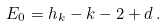<formula> <loc_0><loc_0><loc_500><loc_500>E _ { 0 } = h _ { k } - k - 2 + d \, .</formula> 